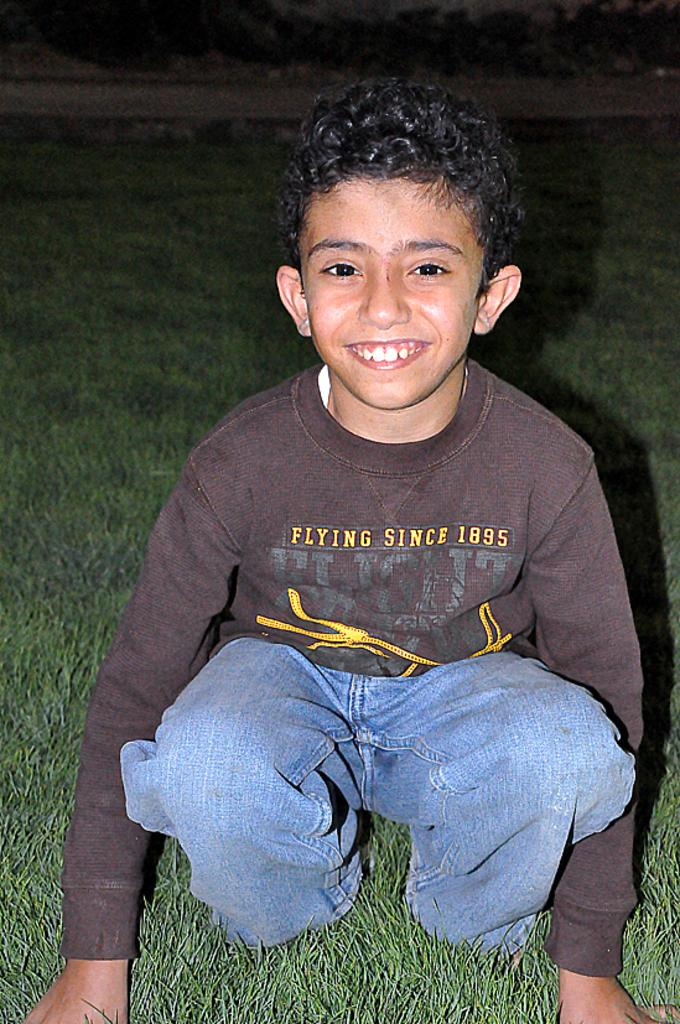Who or what is the main subject of the image? There is a person in the image. Can you describe the person's clothing? The person is wearing a brown shirt and blue color pants. What can be seen in the background of the image? The background of the image includes grass. What is the color of the grass? The grass is green in color. What type of crate is being used by the person in the image? There is no crate present in the image; the person is wearing a brown shirt and blue color pants, and the background includes green grass. 